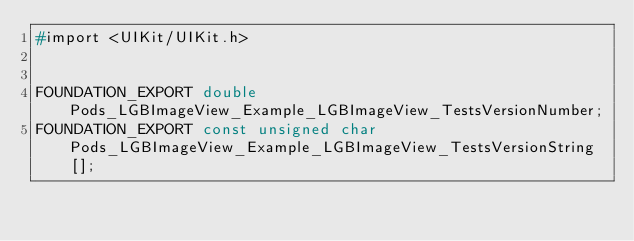<code> <loc_0><loc_0><loc_500><loc_500><_C_>#import <UIKit/UIKit.h>


FOUNDATION_EXPORT double Pods_LGBImageView_Example_LGBImageView_TestsVersionNumber;
FOUNDATION_EXPORT const unsigned char Pods_LGBImageView_Example_LGBImageView_TestsVersionString[];

</code> 